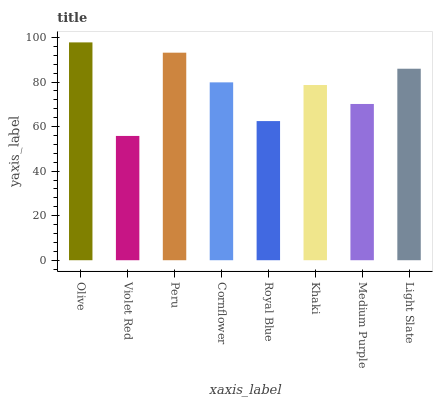Is Violet Red the minimum?
Answer yes or no. Yes. Is Olive the maximum?
Answer yes or no. Yes. Is Peru the minimum?
Answer yes or no. No. Is Peru the maximum?
Answer yes or no. No. Is Peru greater than Violet Red?
Answer yes or no. Yes. Is Violet Red less than Peru?
Answer yes or no. Yes. Is Violet Red greater than Peru?
Answer yes or no. No. Is Peru less than Violet Red?
Answer yes or no. No. Is Cornflower the high median?
Answer yes or no. Yes. Is Khaki the low median?
Answer yes or no. Yes. Is Peru the high median?
Answer yes or no. No. Is Light Slate the low median?
Answer yes or no. No. 